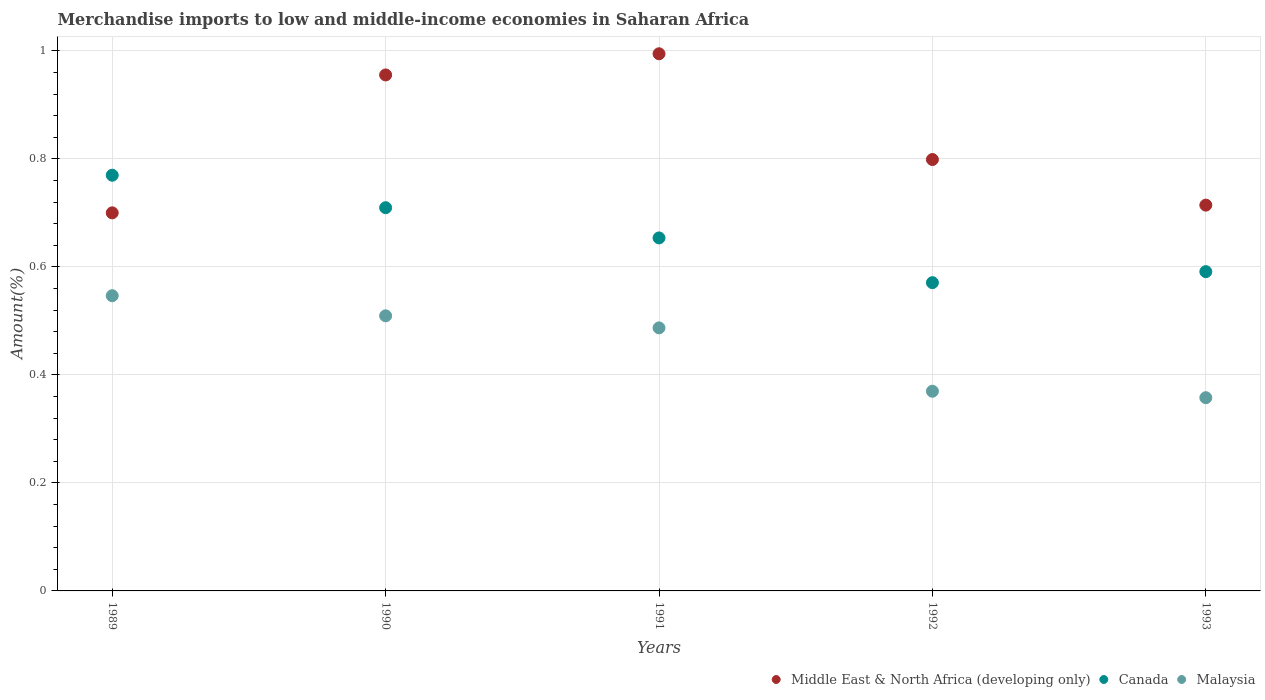How many different coloured dotlines are there?
Offer a terse response. 3. Is the number of dotlines equal to the number of legend labels?
Provide a succinct answer. Yes. What is the percentage of amount earned from merchandise imports in Middle East & North Africa (developing only) in 1992?
Ensure brevity in your answer.  0.8. Across all years, what is the maximum percentage of amount earned from merchandise imports in Canada?
Your answer should be very brief. 0.77. Across all years, what is the minimum percentage of amount earned from merchandise imports in Malaysia?
Offer a very short reply. 0.36. In which year was the percentage of amount earned from merchandise imports in Middle East & North Africa (developing only) maximum?
Give a very brief answer. 1991. What is the total percentage of amount earned from merchandise imports in Canada in the graph?
Your answer should be compact. 3.29. What is the difference between the percentage of amount earned from merchandise imports in Canada in 1991 and that in 1992?
Keep it short and to the point. 0.08. What is the difference between the percentage of amount earned from merchandise imports in Middle East & North Africa (developing only) in 1989 and the percentage of amount earned from merchandise imports in Malaysia in 1990?
Offer a very short reply. 0.19. What is the average percentage of amount earned from merchandise imports in Middle East & North Africa (developing only) per year?
Make the answer very short. 0.83. In the year 1992, what is the difference between the percentage of amount earned from merchandise imports in Malaysia and percentage of amount earned from merchandise imports in Middle East & North Africa (developing only)?
Provide a short and direct response. -0.43. In how many years, is the percentage of amount earned from merchandise imports in Canada greater than 0.04 %?
Make the answer very short. 5. What is the ratio of the percentage of amount earned from merchandise imports in Malaysia in 1990 to that in 1993?
Offer a very short reply. 1.42. Is the percentage of amount earned from merchandise imports in Canada in 1991 less than that in 1993?
Offer a terse response. No. Is the difference between the percentage of amount earned from merchandise imports in Malaysia in 1989 and 1993 greater than the difference between the percentage of amount earned from merchandise imports in Middle East & North Africa (developing only) in 1989 and 1993?
Your response must be concise. Yes. What is the difference between the highest and the second highest percentage of amount earned from merchandise imports in Canada?
Ensure brevity in your answer.  0.06. What is the difference between the highest and the lowest percentage of amount earned from merchandise imports in Malaysia?
Your answer should be very brief. 0.19. Is the sum of the percentage of amount earned from merchandise imports in Malaysia in 1989 and 1990 greater than the maximum percentage of amount earned from merchandise imports in Middle East & North Africa (developing only) across all years?
Give a very brief answer. Yes. Is it the case that in every year, the sum of the percentage of amount earned from merchandise imports in Malaysia and percentage of amount earned from merchandise imports in Middle East & North Africa (developing only)  is greater than the percentage of amount earned from merchandise imports in Canada?
Give a very brief answer. Yes. Does the percentage of amount earned from merchandise imports in Middle East & North Africa (developing only) monotonically increase over the years?
Keep it short and to the point. No. Is the percentage of amount earned from merchandise imports in Middle East & North Africa (developing only) strictly greater than the percentage of amount earned from merchandise imports in Malaysia over the years?
Ensure brevity in your answer.  Yes. Is the percentage of amount earned from merchandise imports in Middle East & North Africa (developing only) strictly less than the percentage of amount earned from merchandise imports in Canada over the years?
Keep it short and to the point. No. How many dotlines are there?
Your answer should be compact. 3. How many years are there in the graph?
Ensure brevity in your answer.  5. Are the values on the major ticks of Y-axis written in scientific E-notation?
Provide a succinct answer. No. Does the graph contain grids?
Your answer should be very brief. Yes. What is the title of the graph?
Your answer should be very brief. Merchandise imports to low and middle-income economies in Saharan Africa. What is the label or title of the X-axis?
Keep it short and to the point. Years. What is the label or title of the Y-axis?
Make the answer very short. Amount(%). What is the Amount(%) in Middle East & North Africa (developing only) in 1989?
Provide a succinct answer. 0.7. What is the Amount(%) of Canada in 1989?
Your answer should be very brief. 0.77. What is the Amount(%) of Malaysia in 1989?
Give a very brief answer. 0.55. What is the Amount(%) of Middle East & North Africa (developing only) in 1990?
Offer a terse response. 0.96. What is the Amount(%) of Canada in 1990?
Give a very brief answer. 0.71. What is the Amount(%) in Malaysia in 1990?
Give a very brief answer. 0.51. What is the Amount(%) of Middle East & North Africa (developing only) in 1991?
Ensure brevity in your answer.  0.99. What is the Amount(%) in Canada in 1991?
Your answer should be compact. 0.65. What is the Amount(%) of Malaysia in 1991?
Give a very brief answer. 0.49. What is the Amount(%) of Middle East & North Africa (developing only) in 1992?
Your response must be concise. 0.8. What is the Amount(%) in Canada in 1992?
Keep it short and to the point. 0.57. What is the Amount(%) of Malaysia in 1992?
Offer a terse response. 0.37. What is the Amount(%) of Middle East & North Africa (developing only) in 1993?
Provide a succinct answer. 0.71. What is the Amount(%) of Canada in 1993?
Your answer should be very brief. 0.59. What is the Amount(%) in Malaysia in 1993?
Keep it short and to the point. 0.36. Across all years, what is the maximum Amount(%) in Middle East & North Africa (developing only)?
Your answer should be very brief. 0.99. Across all years, what is the maximum Amount(%) of Canada?
Your answer should be very brief. 0.77. Across all years, what is the maximum Amount(%) of Malaysia?
Offer a very short reply. 0.55. Across all years, what is the minimum Amount(%) in Middle East & North Africa (developing only)?
Provide a short and direct response. 0.7. Across all years, what is the minimum Amount(%) of Canada?
Provide a succinct answer. 0.57. Across all years, what is the minimum Amount(%) of Malaysia?
Your answer should be very brief. 0.36. What is the total Amount(%) of Middle East & North Africa (developing only) in the graph?
Your answer should be very brief. 4.16. What is the total Amount(%) of Canada in the graph?
Your answer should be very brief. 3.29. What is the total Amount(%) of Malaysia in the graph?
Your answer should be very brief. 2.27. What is the difference between the Amount(%) of Middle East & North Africa (developing only) in 1989 and that in 1990?
Offer a terse response. -0.26. What is the difference between the Amount(%) of Canada in 1989 and that in 1990?
Your answer should be very brief. 0.06. What is the difference between the Amount(%) in Malaysia in 1989 and that in 1990?
Offer a terse response. 0.04. What is the difference between the Amount(%) of Middle East & North Africa (developing only) in 1989 and that in 1991?
Give a very brief answer. -0.29. What is the difference between the Amount(%) of Canada in 1989 and that in 1991?
Ensure brevity in your answer.  0.12. What is the difference between the Amount(%) in Malaysia in 1989 and that in 1991?
Provide a succinct answer. 0.06. What is the difference between the Amount(%) in Middle East & North Africa (developing only) in 1989 and that in 1992?
Provide a short and direct response. -0.1. What is the difference between the Amount(%) in Canada in 1989 and that in 1992?
Keep it short and to the point. 0.2. What is the difference between the Amount(%) in Malaysia in 1989 and that in 1992?
Ensure brevity in your answer.  0.18. What is the difference between the Amount(%) in Middle East & North Africa (developing only) in 1989 and that in 1993?
Make the answer very short. -0.01. What is the difference between the Amount(%) of Canada in 1989 and that in 1993?
Ensure brevity in your answer.  0.18. What is the difference between the Amount(%) in Malaysia in 1989 and that in 1993?
Provide a short and direct response. 0.19. What is the difference between the Amount(%) in Middle East & North Africa (developing only) in 1990 and that in 1991?
Make the answer very short. -0.04. What is the difference between the Amount(%) of Canada in 1990 and that in 1991?
Keep it short and to the point. 0.06. What is the difference between the Amount(%) in Malaysia in 1990 and that in 1991?
Offer a very short reply. 0.02. What is the difference between the Amount(%) in Middle East & North Africa (developing only) in 1990 and that in 1992?
Make the answer very short. 0.16. What is the difference between the Amount(%) in Canada in 1990 and that in 1992?
Offer a very short reply. 0.14. What is the difference between the Amount(%) in Malaysia in 1990 and that in 1992?
Give a very brief answer. 0.14. What is the difference between the Amount(%) in Middle East & North Africa (developing only) in 1990 and that in 1993?
Provide a succinct answer. 0.24. What is the difference between the Amount(%) in Canada in 1990 and that in 1993?
Give a very brief answer. 0.12. What is the difference between the Amount(%) in Malaysia in 1990 and that in 1993?
Ensure brevity in your answer.  0.15. What is the difference between the Amount(%) in Middle East & North Africa (developing only) in 1991 and that in 1992?
Offer a terse response. 0.2. What is the difference between the Amount(%) in Canada in 1991 and that in 1992?
Provide a succinct answer. 0.08. What is the difference between the Amount(%) of Malaysia in 1991 and that in 1992?
Give a very brief answer. 0.12. What is the difference between the Amount(%) in Middle East & North Africa (developing only) in 1991 and that in 1993?
Offer a terse response. 0.28. What is the difference between the Amount(%) of Canada in 1991 and that in 1993?
Offer a terse response. 0.06. What is the difference between the Amount(%) of Malaysia in 1991 and that in 1993?
Make the answer very short. 0.13. What is the difference between the Amount(%) in Middle East & North Africa (developing only) in 1992 and that in 1993?
Ensure brevity in your answer.  0.08. What is the difference between the Amount(%) of Canada in 1992 and that in 1993?
Your answer should be very brief. -0.02. What is the difference between the Amount(%) of Malaysia in 1992 and that in 1993?
Ensure brevity in your answer.  0.01. What is the difference between the Amount(%) of Middle East & North Africa (developing only) in 1989 and the Amount(%) of Canada in 1990?
Your answer should be very brief. -0.01. What is the difference between the Amount(%) of Middle East & North Africa (developing only) in 1989 and the Amount(%) of Malaysia in 1990?
Your answer should be very brief. 0.19. What is the difference between the Amount(%) in Canada in 1989 and the Amount(%) in Malaysia in 1990?
Give a very brief answer. 0.26. What is the difference between the Amount(%) in Middle East & North Africa (developing only) in 1989 and the Amount(%) in Canada in 1991?
Provide a short and direct response. 0.05. What is the difference between the Amount(%) of Middle East & North Africa (developing only) in 1989 and the Amount(%) of Malaysia in 1991?
Keep it short and to the point. 0.21. What is the difference between the Amount(%) in Canada in 1989 and the Amount(%) in Malaysia in 1991?
Your response must be concise. 0.28. What is the difference between the Amount(%) of Middle East & North Africa (developing only) in 1989 and the Amount(%) of Canada in 1992?
Provide a succinct answer. 0.13. What is the difference between the Amount(%) of Middle East & North Africa (developing only) in 1989 and the Amount(%) of Malaysia in 1992?
Provide a succinct answer. 0.33. What is the difference between the Amount(%) in Canada in 1989 and the Amount(%) in Malaysia in 1992?
Keep it short and to the point. 0.4. What is the difference between the Amount(%) of Middle East & North Africa (developing only) in 1989 and the Amount(%) of Canada in 1993?
Your response must be concise. 0.11. What is the difference between the Amount(%) in Middle East & North Africa (developing only) in 1989 and the Amount(%) in Malaysia in 1993?
Your response must be concise. 0.34. What is the difference between the Amount(%) in Canada in 1989 and the Amount(%) in Malaysia in 1993?
Provide a succinct answer. 0.41. What is the difference between the Amount(%) in Middle East & North Africa (developing only) in 1990 and the Amount(%) in Canada in 1991?
Make the answer very short. 0.3. What is the difference between the Amount(%) in Middle East & North Africa (developing only) in 1990 and the Amount(%) in Malaysia in 1991?
Offer a very short reply. 0.47. What is the difference between the Amount(%) in Canada in 1990 and the Amount(%) in Malaysia in 1991?
Offer a very short reply. 0.22. What is the difference between the Amount(%) in Middle East & North Africa (developing only) in 1990 and the Amount(%) in Canada in 1992?
Your answer should be compact. 0.38. What is the difference between the Amount(%) in Middle East & North Africa (developing only) in 1990 and the Amount(%) in Malaysia in 1992?
Provide a succinct answer. 0.59. What is the difference between the Amount(%) of Canada in 1990 and the Amount(%) of Malaysia in 1992?
Give a very brief answer. 0.34. What is the difference between the Amount(%) in Middle East & North Africa (developing only) in 1990 and the Amount(%) in Canada in 1993?
Provide a succinct answer. 0.36. What is the difference between the Amount(%) of Middle East & North Africa (developing only) in 1990 and the Amount(%) of Malaysia in 1993?
Provide a short and direct response. 0.6. What is the difference between the Amount(%) of Canada in 1990 and the Amount(%) of Malaysia in 1993?
Provide a short and direct response. 0.35. What is the difference between the Amount(%) in Middle East & North Africa (developing only) in 1991 and the Amount(%) in Canada in 1992?
Ensure brevity in your answer.  0.42. What is the difference between the Amount(%) of Middle East & North Africa (developing only) in 1991 and the Amount(%) of Malaysia in 1992?
Offer a very short reply. 0.62. What is the difference between the Amount(%) of Canada in 1991 and the Amount(%) of Malaysia in 1992?
Your response must be concise. 0.28. What is the difference between the Amount(%) of Middle East & North Africa (developing only) in 1991 and the Amount(%) of Canada in 1993?
Make the answer very short. 0.4. What is the difference between the Amount(%) in Middle East & North Africa (developing only) in 1991 and the Amount(%) in Malaysia in 1993?
Make the answer very short. 0.64. What is the difference between the Amount(%) of Canada in 1991 and the Amount(%) of Malaysia in 1993?
Offer a very short reply. 0.3. What is the difference between the Amount(%) of Middle East & North Africa (developing only) in 1992 and the Amount(%) of Canada in 1993?
Give a very brief answer. 0.21. What is the difference between the Amount(%) of Middle East & North Africa (developing only) in 1992 and the Amount(%) of Malaysia in 1993?
Offer a terse response. 0.44. What is the difference between the Amount(%) of Canada in 1992 and the Amount(%) of Malaysia in 1993?
Offer a very short reply. 0.21. What is the average Amount(%) of Middle East & North Africa (developing only) per year?
Offer a terse response. 0.83. What is the average Amount(%) of Canada per year?
Offer a terse response. 0.66. What is the average Amount(%) in Malaysia per year?
Your answer should be compact. 0.45. In the year 1989, what is the difference between the Amount(%) of Middle East & North Africa (developing only) and Amount(%) of Canada?
Provide a succinct answer. -0.07. In the year 1989, what is the difference between the Amount(%) of Middle East & North Africa (developing only) and Amount(%) of Malaysia?
Offer a terse response. 0.15. In the year 1989, what is the difference between the Amount(%) of Canada and Amount(%) of Malaysia?
Ensure brevity in your answer.  0.22. In the year 1990, what is the difference between the Amount(%) of Middle East & North Africa (developing only) and Amount(%) of Canada?
Provide a short and direct response. 0.25. In the year 1990, what is the difference between the Amount(%) in Middle East & North Africa (developing only) and Amount(%) in Malaysia?
Offer a terse response. 0.45. In the year 1990, what is the difference between the Amount(%) of Canada and Amount(%) of Malaysia?
Offer a very short reply. 0.2. In the year 1991, what is the difference between the Amount(%) of Middle East & North Africa (developing only) and Amount(%) of Canada?
Give a very brief answer. 0.34. In the year 1991, what is the difference between the Amount(%) in Middle East & North Africa (developing only) and Amount(%) in Malaysia?
Your answer should be very brief. 0.51. In the year 1991, what is the difference between the Amount(%) of Canada and Amount(%) of Malaysia?
Your answer should be very brief. 0.17. In the year 1992, what is the difference between the Amount(%) of Middle East & North Africa (developing only) and Amount(%) of Canada?
Provide a short and direct response. 0.23. In the year 1992, what is the difference between the Amount(%) of Middle East & North Africa (developing only) and Amount(%) of Malaysia?
Offer a terse response. 0.43. In the year 1992, what is the difference between the Amount(%) in Canada and Amount(%) in Malaysia?
Your response must be concise. 0.2. In the year 1993, what is the difference between the Amount(%) of Middle East & North Africa (developing only) and Amount(%) of Canada?
Keep it short and to the point. 0.12. In the year 1993, what is the difference between the Amount(%) of Middle East & North Africa (developing only) and Amount(%) of Malaysia?
Ensure brevity in your answer.  0.36. In the year 1993, what is the difference between the Amount(%) of Canada and Amount(%) of Malaysia?
Provide a short and direct response. 0.23. What is the ratio of the Amount(%) in Middle East & North Africa (developing only) in 1989 to that in 1990?
Offer a very short reply. 0.73. What is the ratio of the Amount(%) of Canada in 1989 to that in 1990?
Provide a succinct answer. 1.08. What is the ratio of the Amount(%) in Malaysia in 1989 to that in 1990?
Keep it short and to the point. 1.07. What is the ratio of the Amount(%) of Middle East & North Africa (developing only) in 1989 to that in 1991?
Offer a very short reply. 0.7. What is the ratio of the Amount(%) in Canada in 1989 to that in 1991?
Ensure brevity in your answer.  1.18. What is the ratio of the Amount(%) of Malaysia in 1989 to that in 1991?
Your answer should be very brief. 1.12. What is the ratio of the Amount(%) in Middle East & North Africa (developing only) in 1989 to that in 1992?
Your answer should be very brief. 0.88. What is the ratio of the Amount(%) of Canada in 1989 to that in 1992?
Your answer should be very brief. 1.35. What is the ratio of the Amount(%) in Malaysia in 1989 to that in 1992?
Offer a very short reply. 1.48. What is the ratio of the Amount(%) in Canada in 1989 to that in 1993?
Give a very brief answer. 1.3. What is the ratio of the Amount(%) in Malaysia in 1989 to that in 1993?
Your answer should be very brief. 1.53. What is the ratio of the Amount(%) in Middle East & North Africa (developing only) in 1990 to that in 1991?
Your response must be concise. 0.96. What is the ratio of the Amount(%) in Canada in 1990 to that in 1991?
Make the answer very short. 1.09. What is the ratio of the Amount(%) of Malaysia in 1990 to that in 1991?
Offer a very short reply. 1.05. What is the ratio of the Amount(%) of Middle East & North Africa (developing only) in 1990 to that in 1992?
Give a very brief answer. 1.2. What is the ratio of the Amount(%) of Canada in 1990 to that in 1992?
Give a very brief answer. 1.24. What is the ratio of the Amount(%) in Malaysia in 1990 to that in 1992?
Your answer should be very brief. 1.38. What is the ratio of the Amount(%) in Middle East & North Africa (developing only) in 1990 to that in 1993?
Give a very brief answer. 1.34. What is the ratio of the Amount(%) of Canada in 1990 to that in 1993?
Your answer should be very brief. 1.2. What is the ratio of the Amount(%) in Malaysia in 1990 to that in 1993?
Offer a very short reply. 1.42. What is the ratio of the Amount(%) in Middle East & North Africa (developing only) in 1991 to that in 1992?
Provide a short and direct response. 1.25. What is the ratio of the Amount(%) in Canada in 1991 to that in 1992?
Offer a terse response. 1.15. What is the ratio of the Amount(%) in Malaysia in 1991 to that in 1992?
Offer a terse response. 1.32. What is the ratio of the Amount(%) of Middle East & North Africa (developing only) in 1991 to that in 1993?
Give a very brief answer. 1.39. What is the ratio of the Amount(%) in Canada in 1991 to that in 1993?
Offer a terse response. 1.11. What is the ratio of the Amount(%) of Malaysia in 1991 to that in 1993?
Offer a very short reply. 1.36. What is the ratio of the Amount(%) of Middle East & North Africa (developing only) in 1992 to that in 1993?
Offer a very short reply. 1.12. What is the ratio of the Amount(%) in Canada in 1992 to that in 1993?
Your response must be concise. 0.97. What is the ratio of the Amount(%) in Malaysia in 1992 to that in 1993?
Make the answer very short. 1.03. What is the difference between the highest and the second highest Amount(%) in Middle East & North Africa (developing only)?
Your answer should be very brief. 0.04. What is the difference between the highest and the second highest Amount(%) of Canada?
Give a very brief answer. 0.06. What is the difference between the highest and the second highest Amount(%) of Malaysia?
Your response must be concise. 0.04. What is the difference between the highest and the lowest Amount(%) in Middle East & North Africa (developing only)?
Your answer should be very brief. 0.29. What is the difference between the highest and the lowest Amount(%) of Canada?
Your response must be concise. 0.2. What is the difference between the highest and the lowest Amount(%) in Malaysia?
Offer a very short reply. 0.19. 